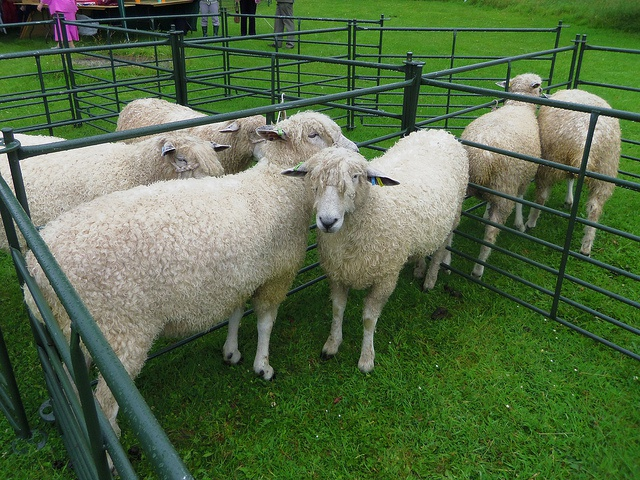Describe the objects in this image and their specific colors. I can see sheep in black, darkgray, gray, and lightgray tones, sheep in black, lightgray, darkgray, and gray tones, sheep in black, lightgray, darkgray, and gray tones, sheep in black, gray, lightgray, and darkgray tones, and sheep in black, darkgray, and gray tones in this image. 